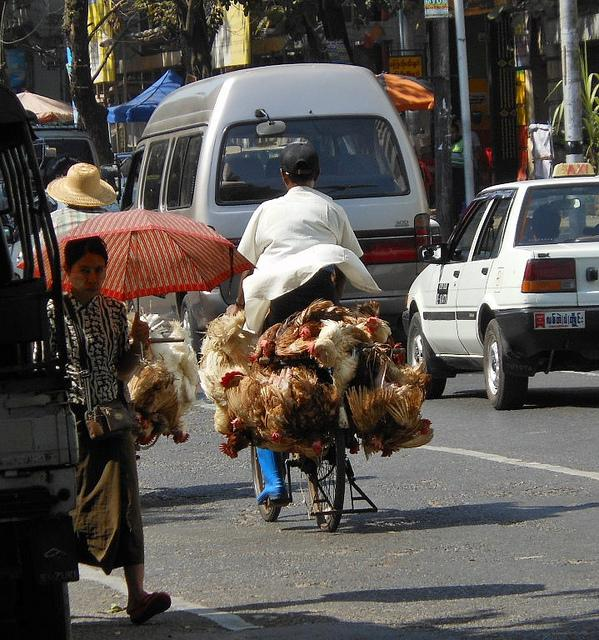What does the man on the bike do for a living? sell chickens 